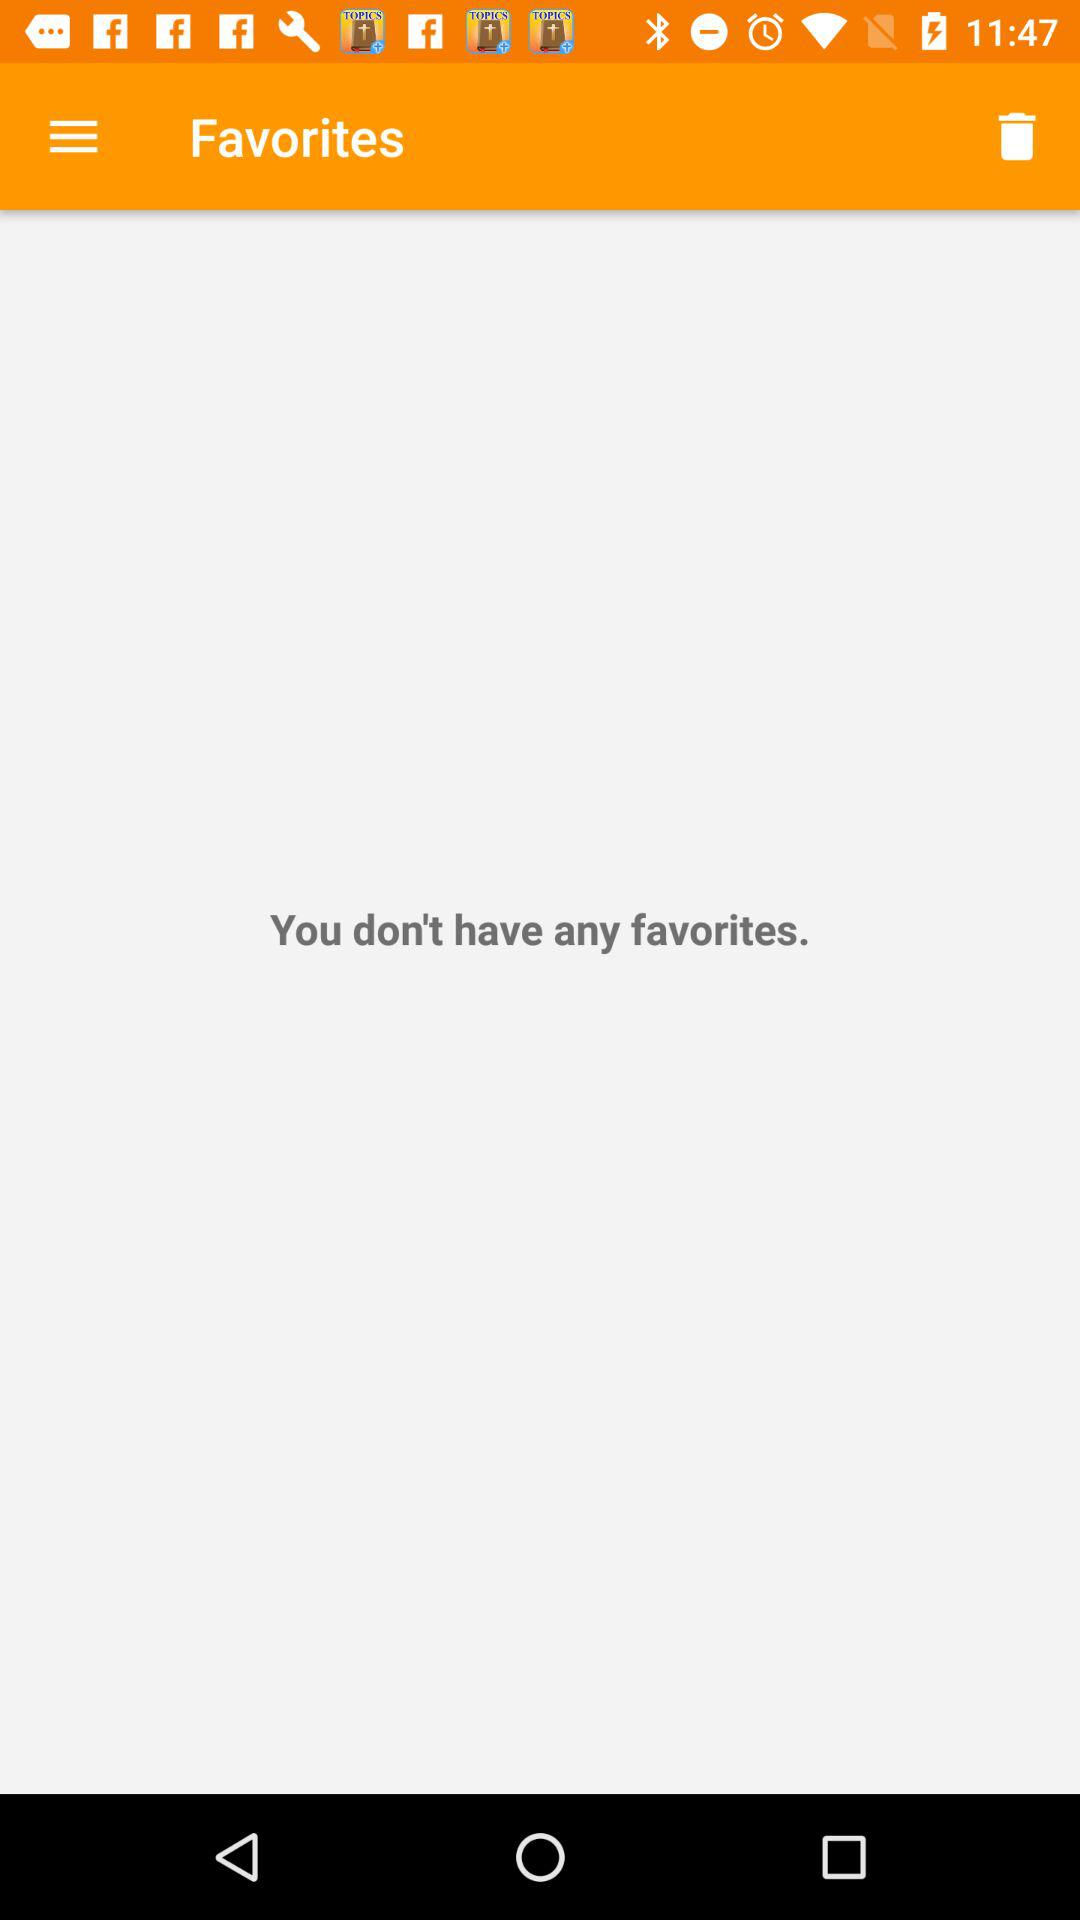How many favorites do you have?
Answer the question using a single word or phrase. 0 